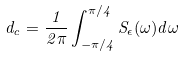<formula> <loc_0><loc_0><loc_500><loc_500>d _ { c } = \frac { 1 } { 2 \pi } \int _ { - \pi / 4 } ^ { \pi / 4 } S _ { \epsilon } ( \omega ) d \omega</formula> 